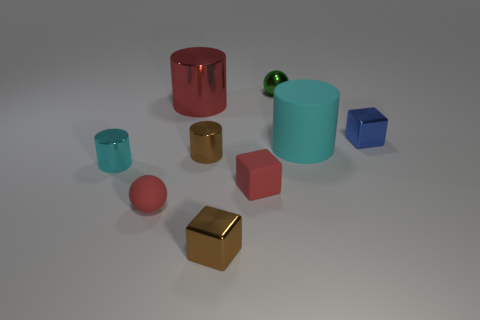Subtract all cyan cylinders. How many were subtracted if there are1cyan cylinders left? 1 Add 1 tiny cyan shiny blocks. How many objects exist? 10 Subtract all red spheres. How many spheres are left? 1 Subtract all cyan matte cylinders. How many cylinders are left? 3 Subtract all purple balls. How many cyan cylinders are left? 2 Subtract all cylinders. How many objects are left? 5 Subtract 1 cubes. How many cubes are left? 2 Subtract all yellow cylinders. Subtract all cyan balls. How many cylinders are left? 4 Subtract all blue shiny cubes. Subtract all red spheres. How many objects are left? 7 Add 7 shiny cubes. How many shiny cubes are left? 9 